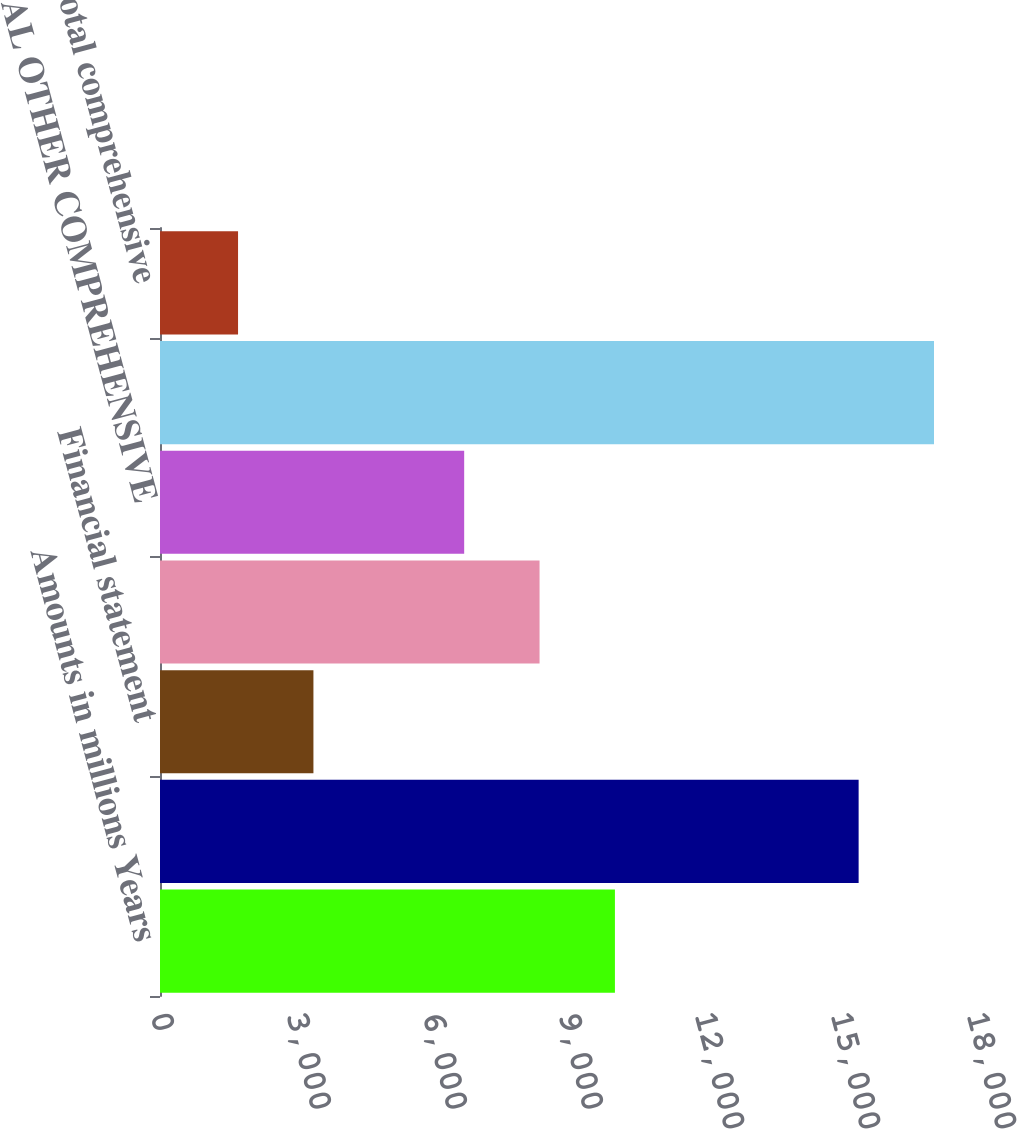Convert chart to OTSL. <chart><loc_0><loc_0><loc_500><loc_500><bar_chart><fcel>Amounts in millions Years<fcel>NET EARNINGS<fcel>Financial statement<fcel>Unrealized gains/(losses) on<fcel>TOTAL OTHER COMPREHENSIVE<fcel>TOTAL COMPREHENSIVE INCOME<fcel>Less Total comprehensive<nl><fcel>10035.2<fcel>15411<fcel>3384.4<fcel>8372.5<fcel>6709.8<fcel>17073.7<fcel>1721.7<nl></chart> 